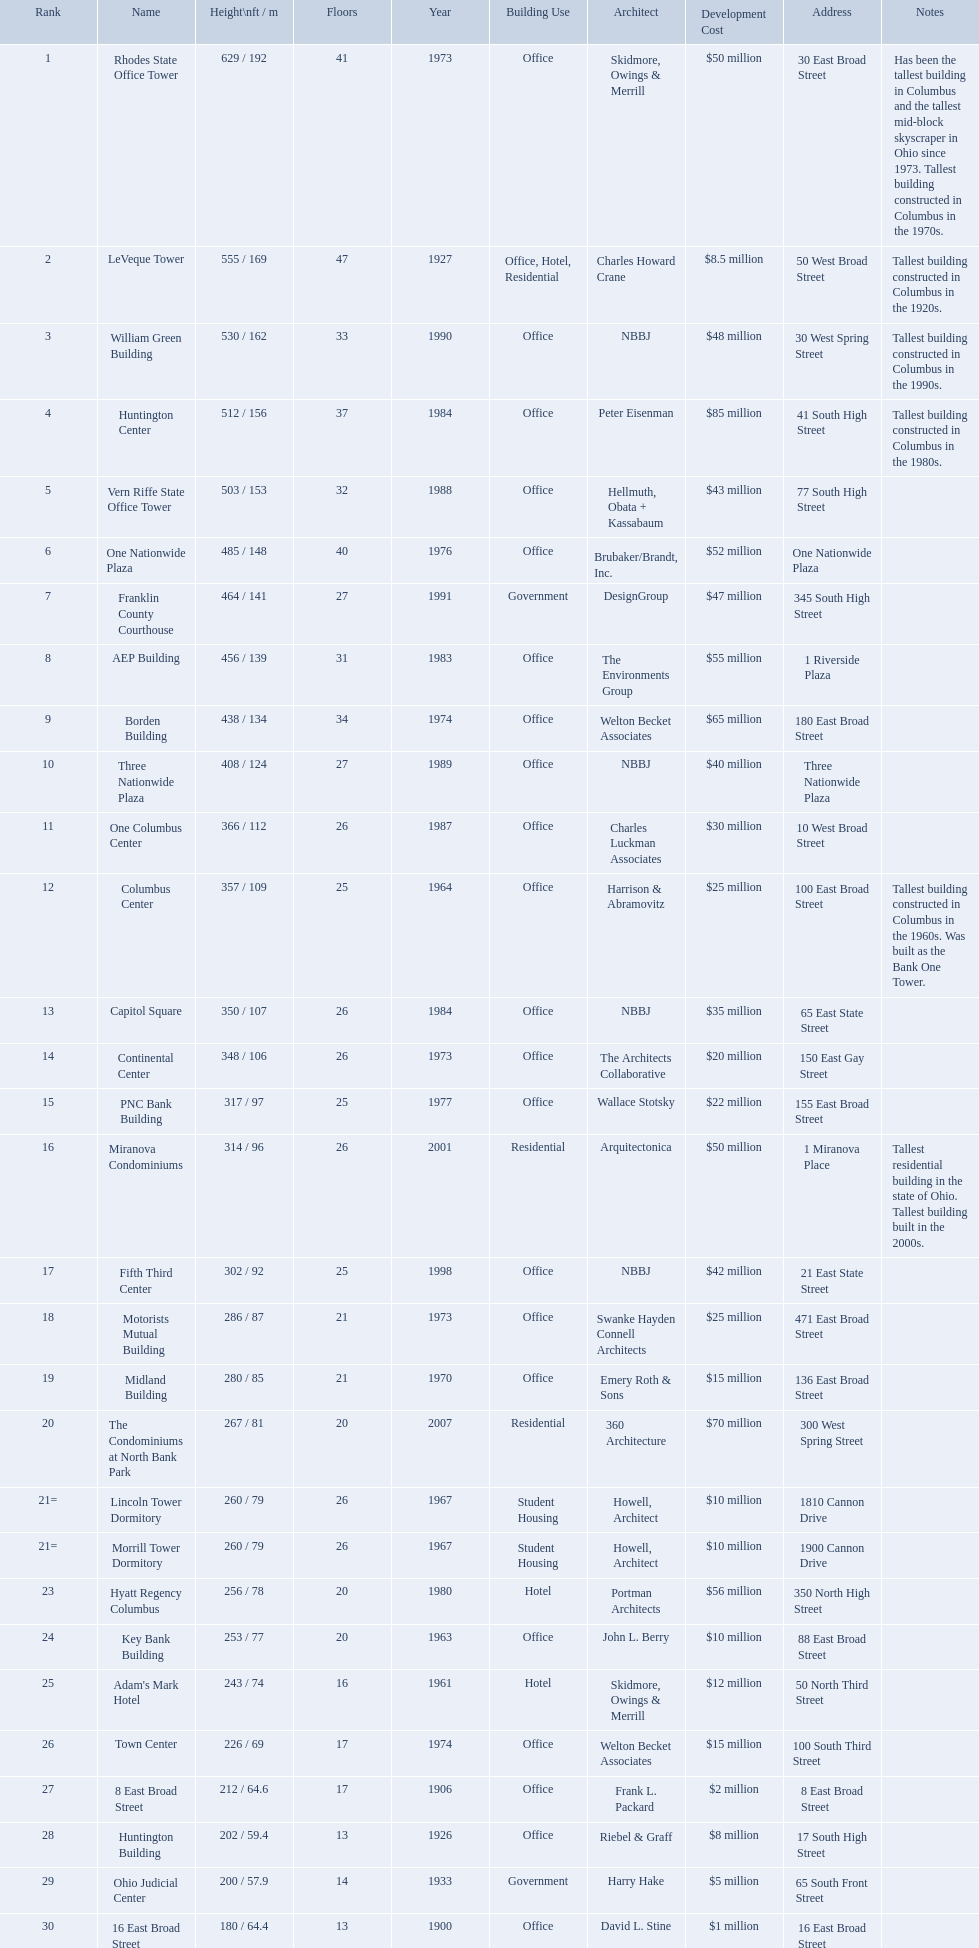How tall is the aep building? 456 / 139. How tall is the one columbus center? 366 / 112. Of these two buildings, which is taller? AEP Building. 